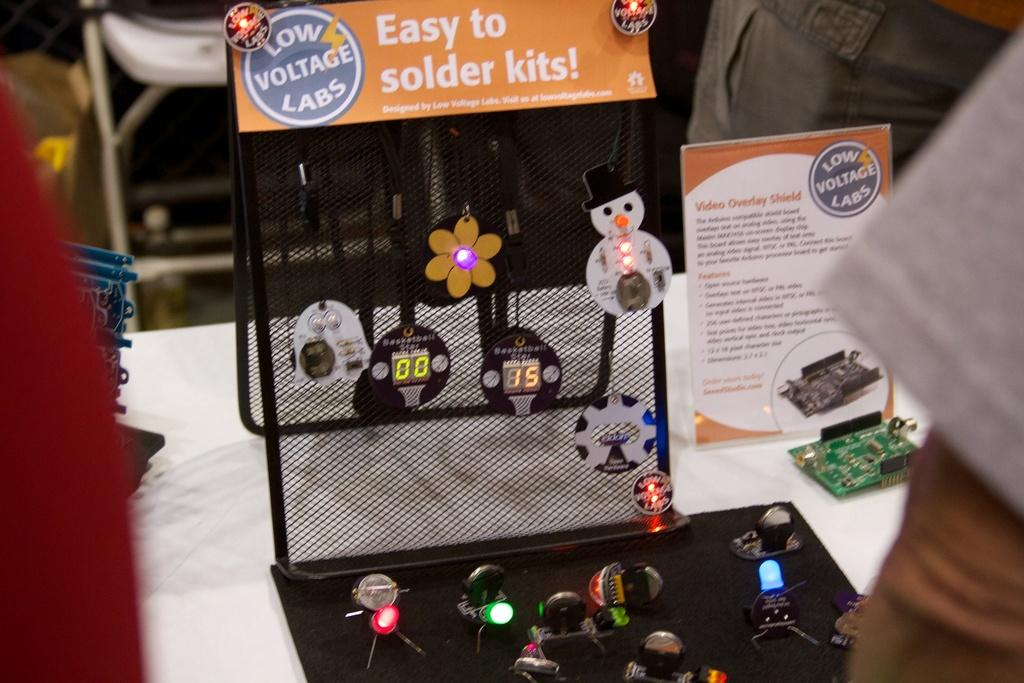What objects can be seen on the table in the image? There are gadgets on a table in the image. Can you describe the location of the chair in the image? The chair is in the top left of the image. What type of steel is used to make the chair in the image? There is no information about the material used to make the chair in the image. Can you describe the protest happening in the image? There is no protest depicted in the image; it only shows gadgets on a table and a chair. 